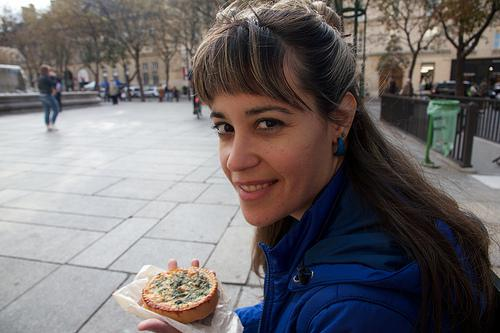Question: what is she holding?
Choices:
A. Something to eat.
B. Pizza.
C. Sandwich.
D. Pasta.
Answer with the letter. Answer: A Question: what color are her eyes?
Choices:
A. Blue.
B. Brown.
C. Green.
D. Hazel.
Answer with the letter. Answer: B Question: where is the woman looking?
Choices:
A. At her husband.
B. At the building.
C. At the camera.
D. At the cameraman.
Answer with the letter. Answer: C 